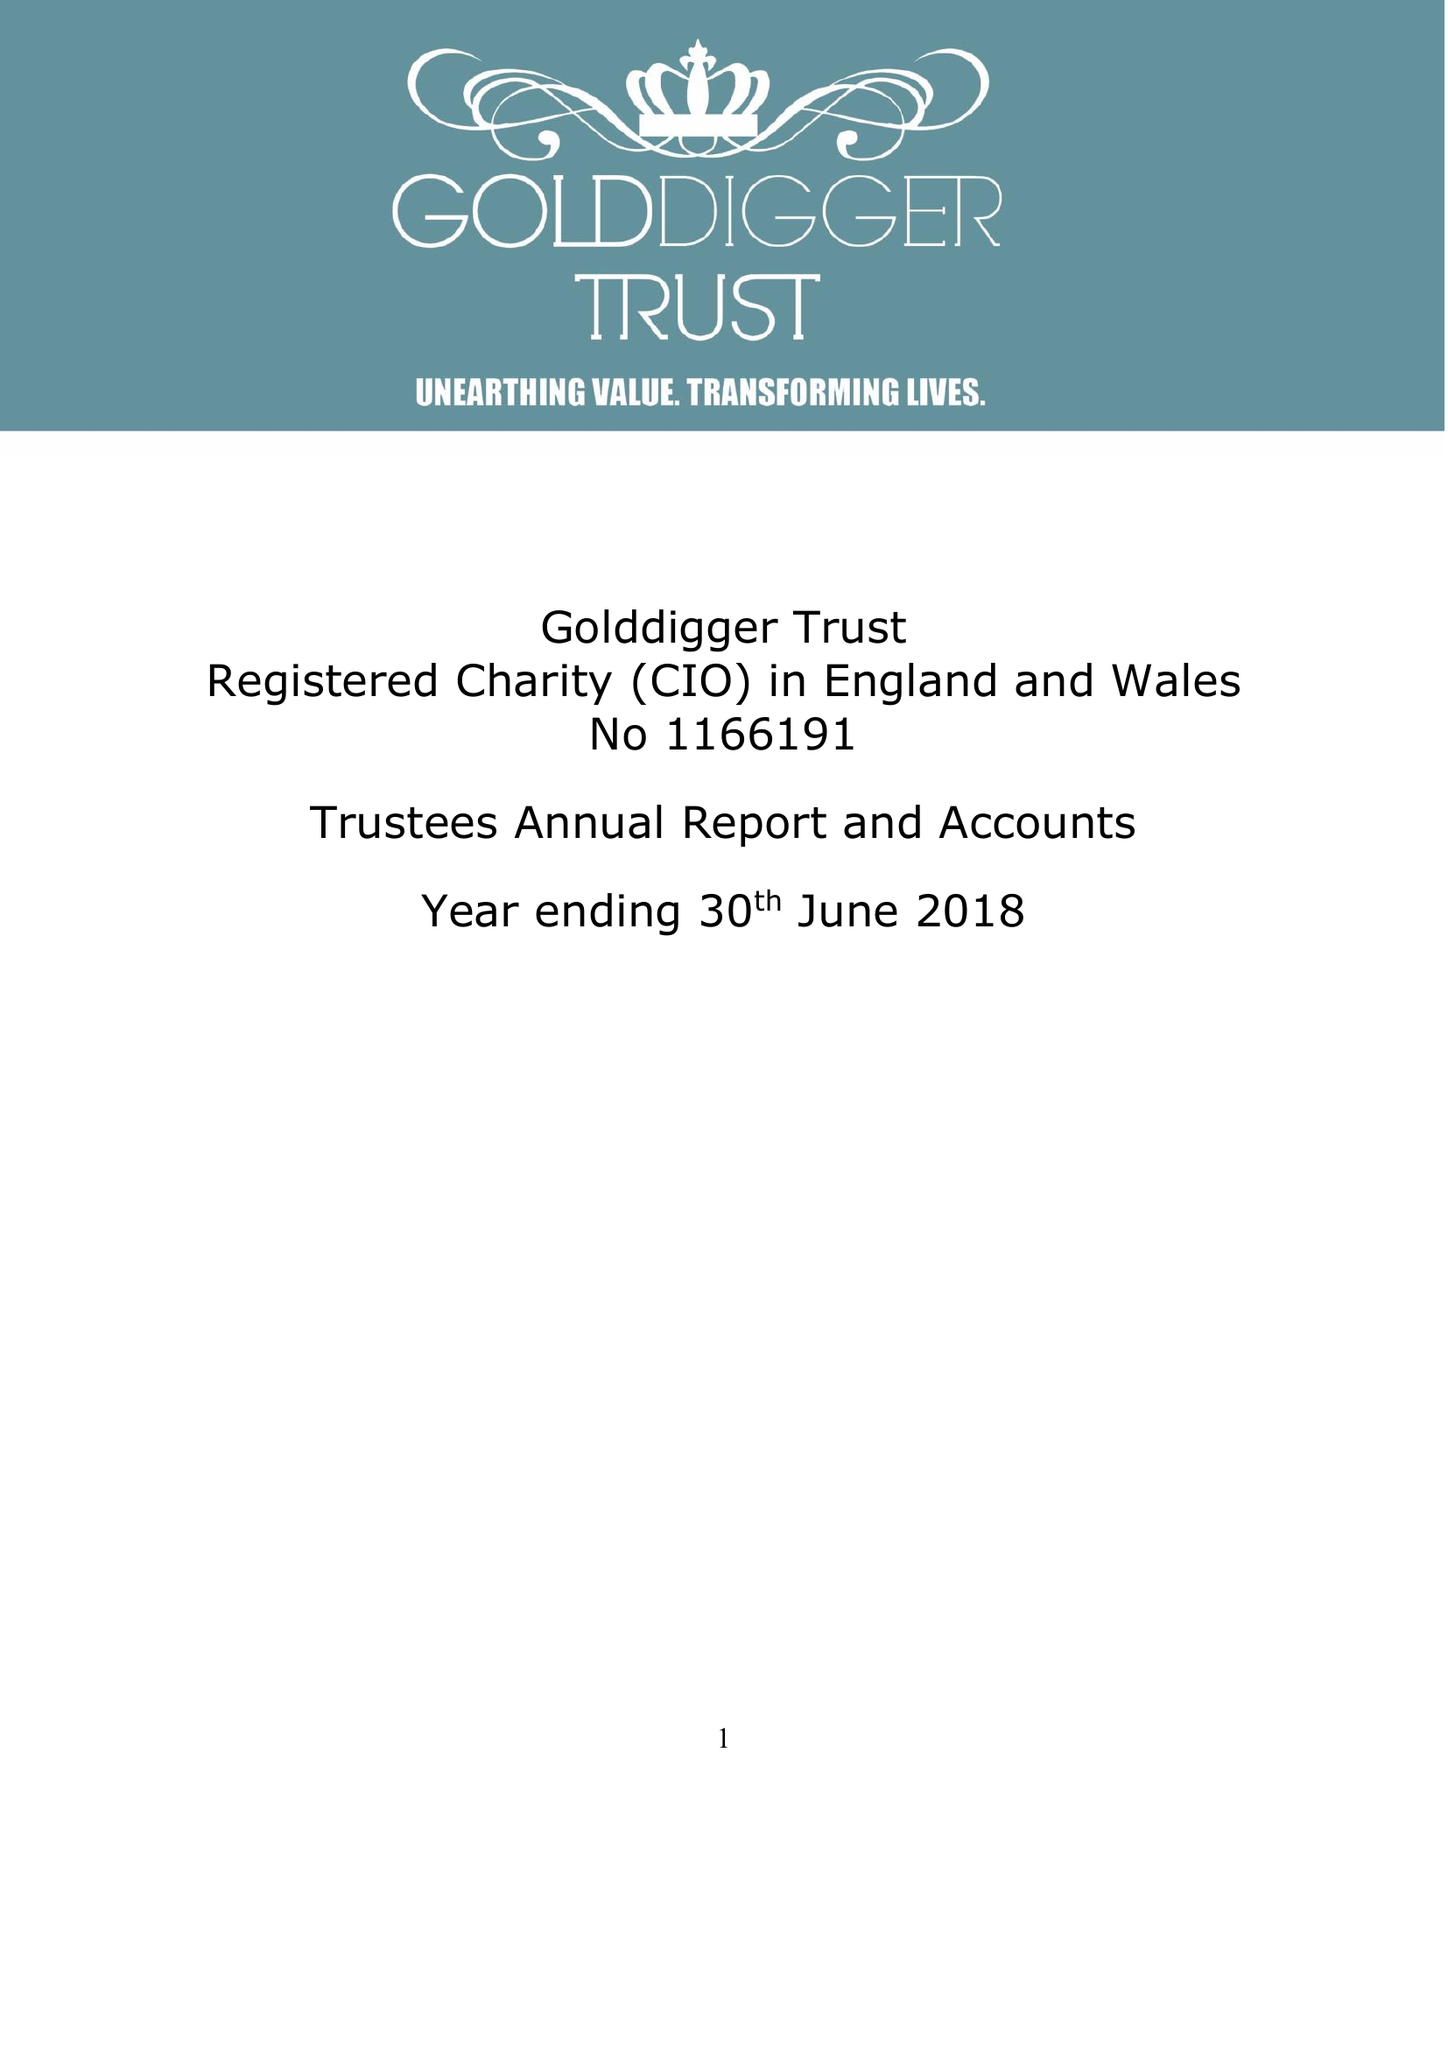What is the value for the address__postcode?
Answer the question using a single word or phrase. S11 8YN 